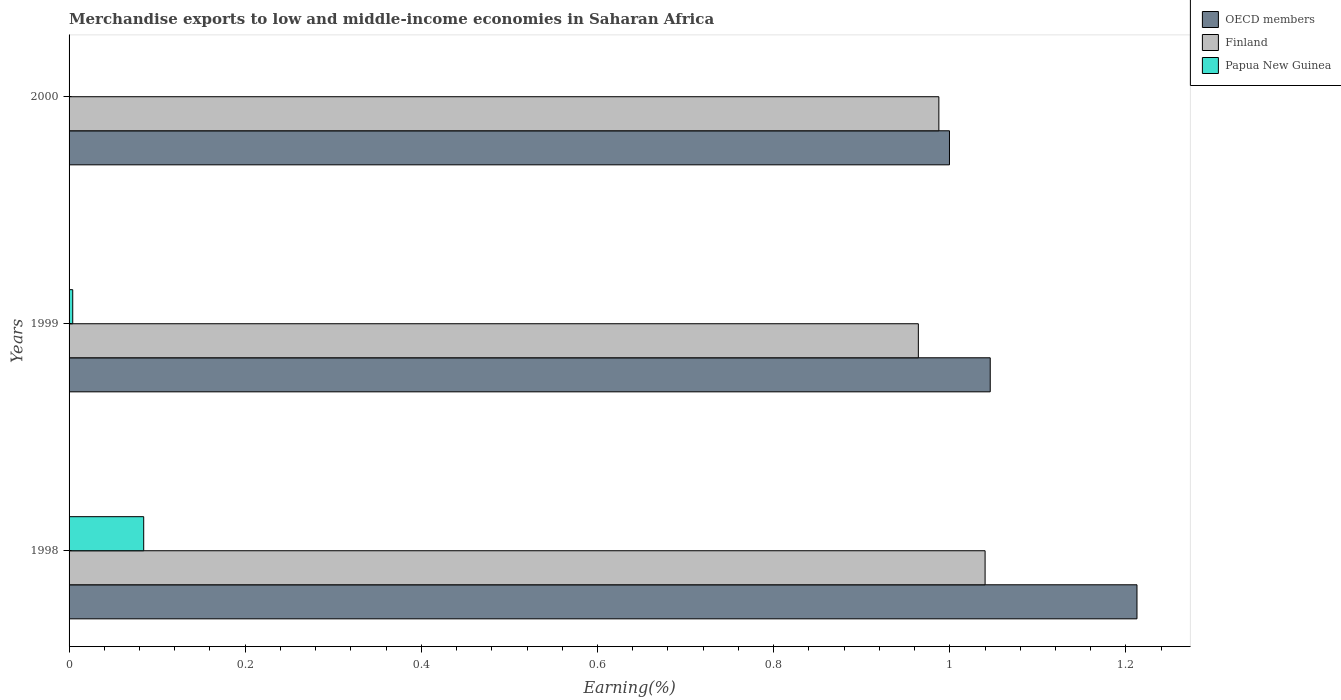How many different coloured bars are there?
Keep it short and to the point. 3. How many bars are there on the 3rd tick from the bottom?
Provide a short and direct response. 3. In how many cases, is the number of bars for a given year not equal to the number of legend labels?
Your answer should be very brief. 0. What is the percentage of amount earned from merchandise exports in Papua New Guinea in 1998?
Provide a succinct answer. 0.08. Across all years, what is the maximum percentage of amount earned from merchandise exports in Finland?
Provide a short and direct response. 1.04. Across all years, what is the minimum percentage of amount earned from merchandise exports in Finland?
Your response must be concise. 0.96. In which year was the percentage of amount earned from merchandise exports in Finland minimum?
Make the answer very short. 1999. What is the total percentage of amount earned from merchandise exports in OECD members in the graph?
Offer a very short reply. 3.26. What is the difference between the percentage of amount earned from merchandise exports in Finland in 1998 and that in 1999?
Ensure brevity in your answer.  0.08. What is the difference between the percentage of amount earned from merchandise exports in Papua New Guinea in 1998 and the percentage of amount earned from merchandise exports in Finland in 1999?
Provide a succinct answer. -0.88. What is the average percentage of amount earned from merchandise exports in Finland per year?
Make the answer very short. 1. In the year 1999, what is the difference between the percentage of amount earned from merchandise exports in OECD members and percentage of amount earned from merchandise exports in Finland?
Your answer should be compact. 0.08. What is the ratio of the percentage of amount earned from merchandise exports in OECD members in 1999 to that in 2000?
Provide a succinct answer. 1.05. Is the percentage of amount earned from merchandise exports in Papua New Guinea in 1998 less than that in 1999?
Give a very brief answer. No. What is the difference between the highest and the second highest percentage of amount earned from merchandise exports in OECD members?
Keep it short and to the point. 0.17. What is the difference between the highest and the lowest percentage of amount earned from merchandise exports in Papua New Guinea?
Ensure brevity in your answer.  0.08. In how many years, is the percentage of amount earned from merchandise exports in OECD members greater than the average percentage of amount earned from merchandise exports in OECD members taken over all years?
Your answer should be very brief. 1. Is the sum of the percentage of amount earned from merchandise exports in Papua New Guinea in 1998 and 1999 greater than the maximum percentage of amount earned from merchandise exports in Finland across all years?
Offer a very short reply. No. What does the 1st bar from the top in 1998 represents?
Ensure brevity in your answer.  Papua New Guinea. What does the 1st bar from the bottom in 1998 represents?
Provide a succinct answer. OECD members. Is it the case that in every year, the sum of the percentage of amount earned from merchandise exports in Finland and percentage of amount earned from merchandise exports in Papua New Guinea is greater than the percentage of amount earned from merchandise exports in OECD members?
Make the answer very short. No. Are all the bars in the graph horizontal?
Keep it short and to the point. Yes. Are the values on the major ticks of X-axis written in scientific E-notation?
Make the answer very short. No. Does the graph contain any zero values?
Keep it short and to the point. No. Does the graph contain grids?
Give a very brief answer. No. What is the title of the graph?
Your response must be concise. Merchandise exports to low and middle-income economies in Saharan Africa. Does "Croatia" appear as one of the legend labels in the graph?
Keep it short and to the point. No. What is the label or title of the X-axis?
Make the answer very short. Earning(%). What is the label or title of the Y-axis?
Your answer should be compact. Years. What is the Earning(%) of OECD members in 1998?
Provide a short and direct response. 1.21. What is the Earning(%) in Finland in 1998?
Offer a terse response. 1.04. What is the Earning(%) in Papua New Guinea in 1998?
Your response must be concise. 0.08. What is the Earning(%) of OECD members in 1999?
Provide a succinct answer. 1.05. What is the Earning(%) in Finland in 1999?
Make the answer very short. 0.96. What is the Earning(%) in Papua New Guinea in 1999?
Your response must be concise. 0. What is the Earning(%) in OECD members in 2000?
Keep it short and to the point. 1. What is the Earning(%) of Finland in 2000?
Keep it short and to the point. 0.99. What is the Earning(%) in Papua New Guinea in 2000?
Provide a short and direct response. 0. Across all years, what is the maximum Earning(%) of OECD members?
Your answer should be compact. 1.21. Across all years, what is the maximum Earning(%) in Finland?
Ensure brevity in your answer.  1.04. Across all years, what is the maximum Earning(%) of Papua New Guinea?
Keep it short and to the point. 0.08. Across all years, what is the minimum Earning(%) in OECD members?
Your answer should be very brief. 1. Across all years, what is the minimum Earning(%) in Finland?
Your answer should be compact. 0.96. Across all years, what is the minimum Earning(%) in Papua New Guinea?
Give a very brief answer. 0. What is the total Earning(%) in OECD members in the graph?
Keep it short and to the point. 3.26. What is the total Earning(%) of Finland in the graph?
Offer a terse response. 2.99. What is the total Earning(%) in Papua New Guinea in the graph?
Provide a short and direct response. 0.09. What is the difference between the Earning(%) in OECD members in 1998 and that in 1999?
Keep it short and to the point. 0.17. What is the difference between the Earning(%) in Finland in 1998 and that in 1999?
Offer a very short reply. 0.08. What is the difference between the Earning(%) in Papua New Guinea in 1998 and that in 1999?
Offer a very short reply. 0.08. What is the difference between the Earning(%) of OECD members in 1998 and that in 2000?
Offer a terse response. 0.21. What is the difference between the Earning(%) in Finland in 1998 and that in 2000?
Ensure brevity in your answer.  0.05. What is the difference between the Earning(%) of Papua New Guinea in 1998 and that in 2000?
Your response must be concise. 0.08. What is the difference between the Earning(%) of OECD members in 1999 and that in 2000?
Make the answer very short. 0.05. What is the difference between the Earning(%) of Finland in 1999 and that in 2000?
Your response must be concise. -0.02. What is the difference between the Earning(%) of Papua New Guinea in 1999 and that in 2000?
Ensure brevity in your answer.  0. What is the difference between the Earning(%) in OECD members in 1998 and the Earning(%) in Finland in 1999?
Ensure brevity in your answer.  0.25. What is the difference between the Earning(%) of OECD members in 1998 and the Earning(%) of Papua New Guinea in 1999?
Keep it short and to the point. 1.21. What is the difference between the Earning(%) of Finland in 1998 and the Earning(%) of Papua New Guinea in 1999?
Your response must be concise. 1.04. What is the difference between the Earning(%) of OECD members in 1998 and the Earning(%) of Finland in 2000?
Provide a short and direct response. 0.23. What is the difference between the Earning(%) in OECD members in 1998 and the Earning(%) in Papua New Guinea in 2000?
Give a very brief answer. 1.21. What is the difference between the Earning(%) in OECD members in 1999 and the Earning(%) in Finland in 2000?
Your response must be concise. 0.06. What is the difference between the Earning(%) in OECD members in 1999 and the Earning(%) in Papua New Guinea in 2000?
Your answer should be very brief. 1.05. What is the difference between the Earning(%) of Finland in 1999 and the Earning(%) of Papua New Guinea in 2000?
Give a very brief answer. 0.96. What is the average Earning(%) of OECD members per year?
Give a very brief answer. 1.09. What is the average Earning(%) of Papua New Guinea per year?
Your response must be concise. 0.03. In the year 1998, what is the difference between the Earning(%) in OECD members and Earning(%) in Finland?
Provide a succinct answer. 0.17. In the year 1998, what is the difference between the Earning(%) in OECD members and Earning(%) in Papua New Guinea?
Provide a short and direct response. 1.13. In the year 1998, what is the difference between the Earning(%) in Finland and Earning(%) in Papua New Guinea?
Offer a very short reply. 0.96. In the year 1999, what is the difference between the Earning(%) in OECD members and Earning(%) in Finland?
Ensure brevity in your answer.  0.08. In the year 1999, what is the difference between the Earning(%) of OECD members and Earning(%) of Papua New Guinea?
Make the answer very short. 1.04. In the year 1999, what is the difference between the Earning(%) of Finland and Earning(%) of Papua New Guinea?
Provide a succinct answer. 0.96. In the year 2000, what is the difference between the Earning(%) in OECD members and Earning(%) in Finland?
Your answer should be very brief. 0.01. In the year 2000, what is the difference between the Earning(%) in OECD members and Earning(%) in Papua New Guinea?
Provide a succinct answer. 1. In the year 2000, what is the difference between the Earning(%) in Finland and Earning(%) in Papua New Guinea?
Provide a succinct answer. 0.99. What is the ratio of the Earning(%) of OECD members in 1998 to that in 1999?
Provide a succinct answer. 1.16. What is the ratio of the Earning(%) of Finland in 1998 to that in 1999?
Offer a very short reply. 1.08. What is the ratio of the Earning(%) in Papua New Guinea in 1998 to that in 1999?
Keep it short and to the point. 20.39. What is the ratio of the Earning(%) of OECD members in 1998 to that in 2000?
Offer a terse response. 1.21. What is the ratio of the Earning(%) of Finland in 1998 to that in 2000?
Your answer should be compact. 1.05. What is the ratio of the Earning(%) in Papua New Guinea in 1998 to that in 2000?
Your answer should be compact. 637.45. What is the ratio of the Earning(%) in OECD members in 1999 to that in 2000?
Keep it short and to the point. 1.05. What is the ratio of the Earning(%) in Finland in 1999 to that in 2000?
Provide a succinct answer. 0.98. What is the ratio of the Earning(%) of Papua New Guinea in 1999 to that in 2000?
Provide a succinct answer. 31.26. What is the difference between the highest and the second highest Earning(%) of OECD members?
Give a very brief answer. 0.17. What is the difference between the highest and the second highest Earning(%) in Finland?
Make the answer very short. 0.05. What is the difference between the highest and the second highest Earning(%) of Papua New Guinea?
Offer a very short reply. 0.08. What is the difference between the highest and the lowest Earning(%) of OECD members?
Your response must be concise. 0.21. What is the difference between the highest and the lowest Earning(%) of Finland?
Your answer should be very brief. 0.08. What is the difference between the highest and the lowest Earning(%) of Papua New Guinea?
Your answer should be very brief. 0.08. 